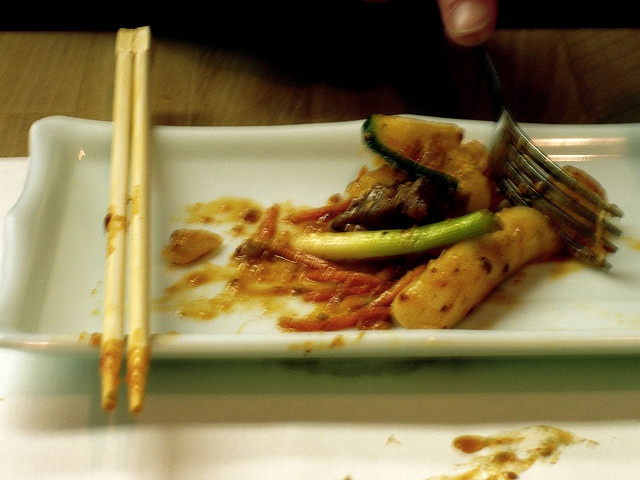Describe the objects in this image and their specific colors. I can see dining table in black, olive, beige, and tan tones, banana in black, olive, and maroon tones, fork in black, maroon, and olive tones, and people in black, maroon, and brown tones in this image. 